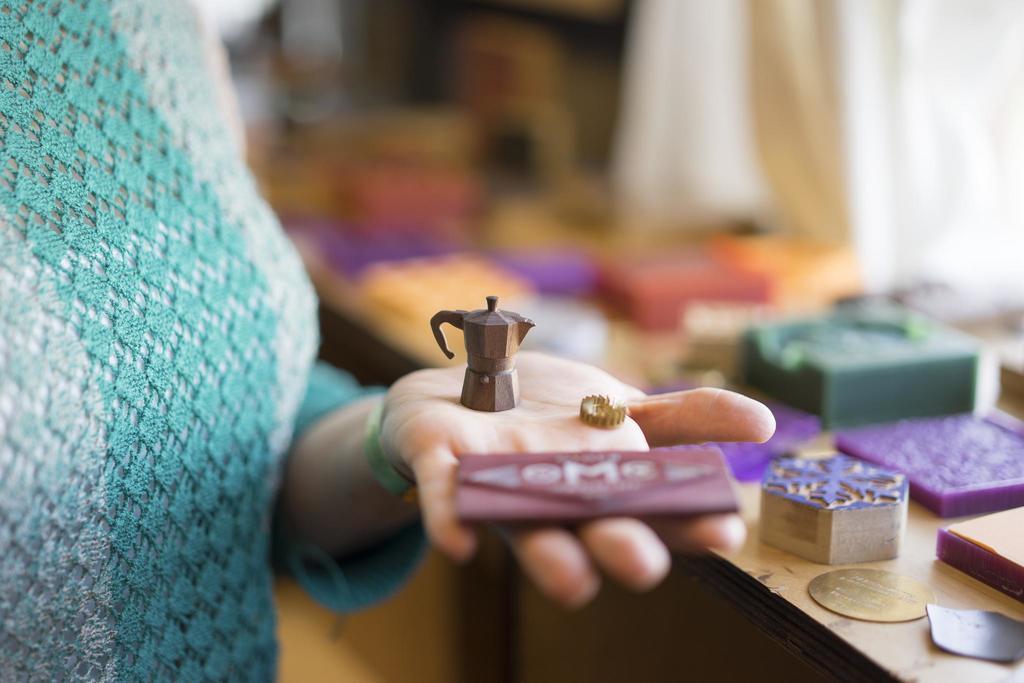Describe this image in one or two sentences. In this image, we can see a human hand with some objects and cloth. Background there is a blur view. Here we can see few things and objects are placed on it. 